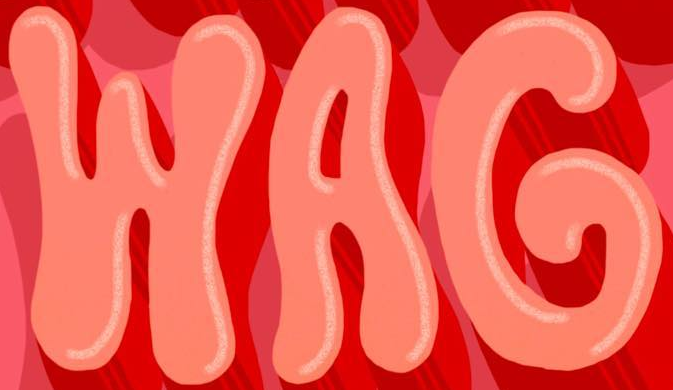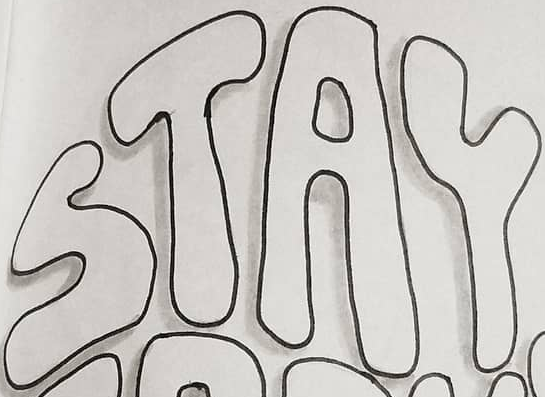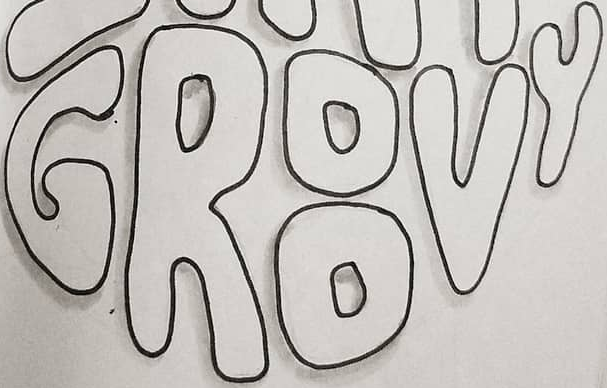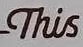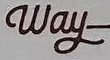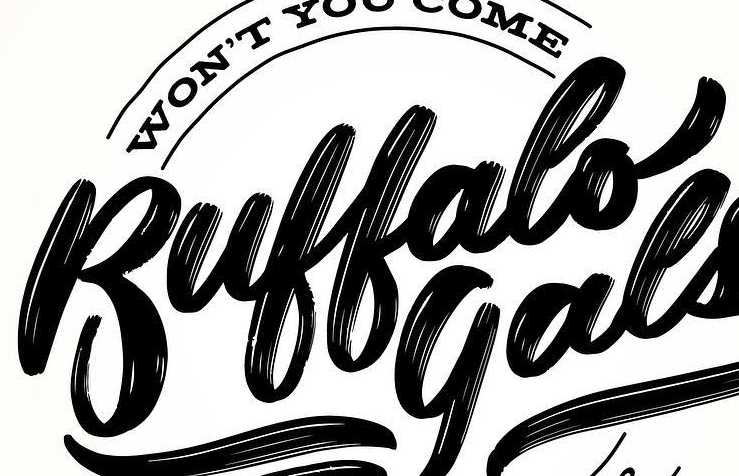Read the text from these images in sequence, separated by a semicolon. WAG; STAY; GROOVY; This; Way; Buffalo 